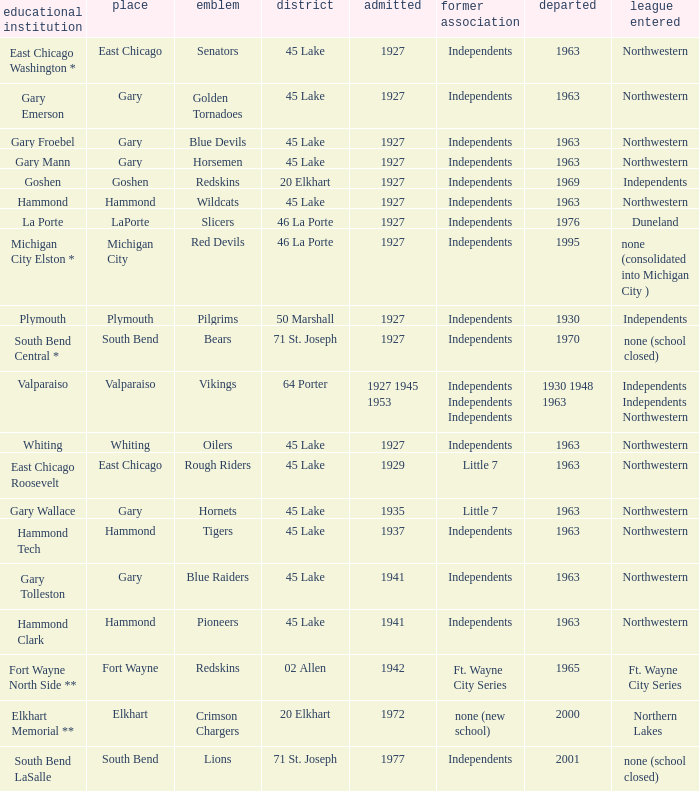When doeas Mascot of blue devils in Gary Froebel School? 1927.0. 